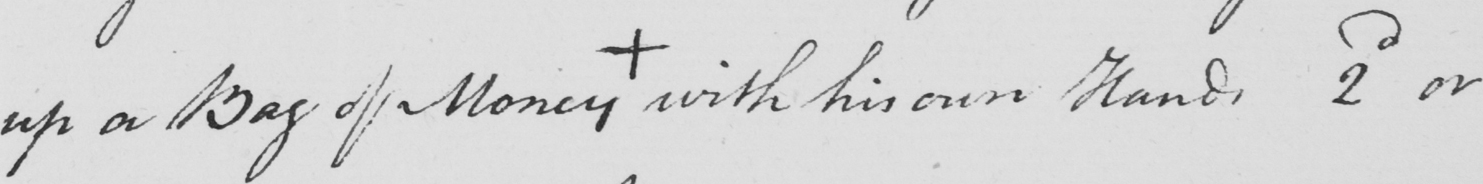What is written in this line of handwriting? up a Bag of Money +  with his own Hands 2nd or 